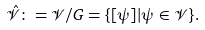Convert formula to latex. <formula><loc_0><loc_0><loc_500><loc_500>\hat { \mathcal { V } } \colon = \mathcal { V } / G = \{ [ \psi ] | \psi \in \mathcal { V } \} .</formula> 